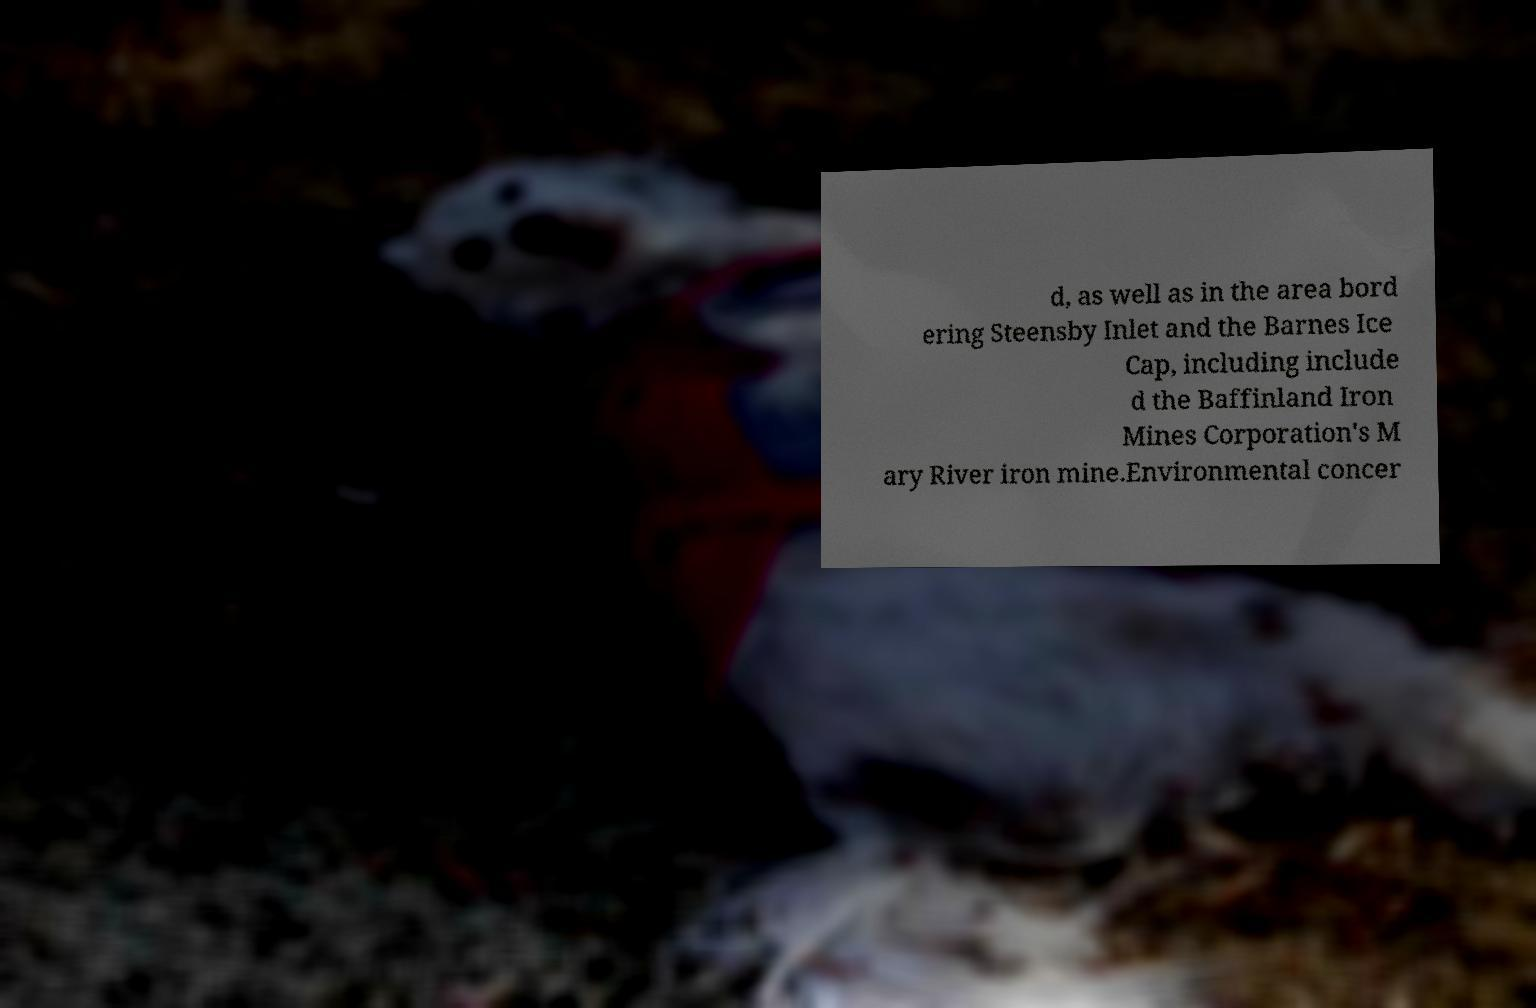Please identify and transcribe the text found in this image. d, as well as in the area bord ering Steensby Inlet and the Barnes Ice Cap, including include d the Baffinland Iron Mines Corporation's M ary River iron mine.Environmental concer 